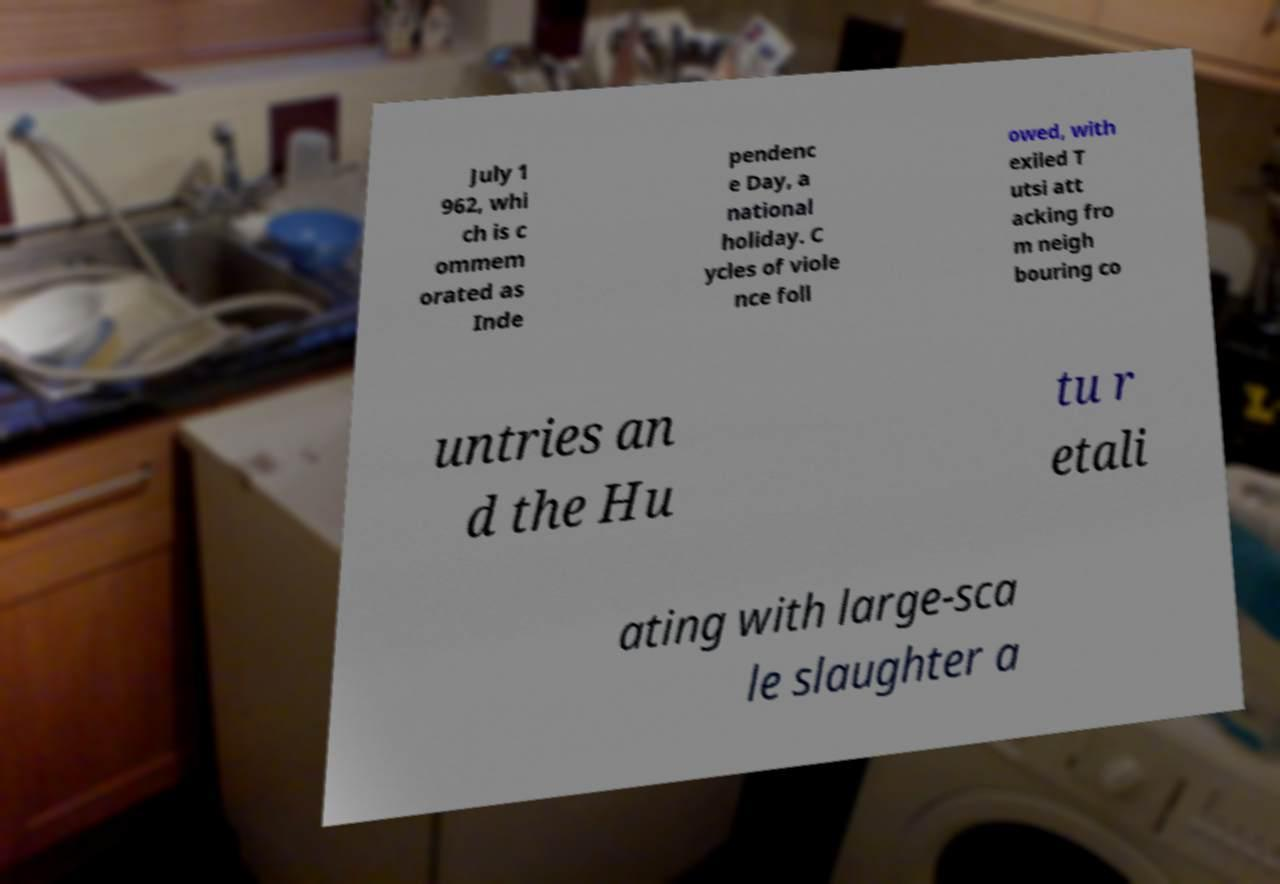For documentation purposes, I need the text within this image transcribed. Could you provide that? July 1 962, whi ch is c ommem orated as Inde pendenc e Day, a national holiday. C ycles of viole nce foll owed, with exiled T utsi att acking fro m neigh bouring co untries an d the Hu tu r etali ating with large-sca le slaughter a 